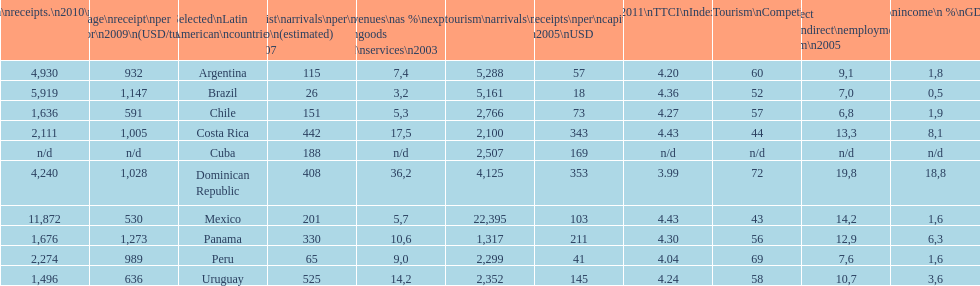What country ranks the best in most categories? Dominican Republic. 